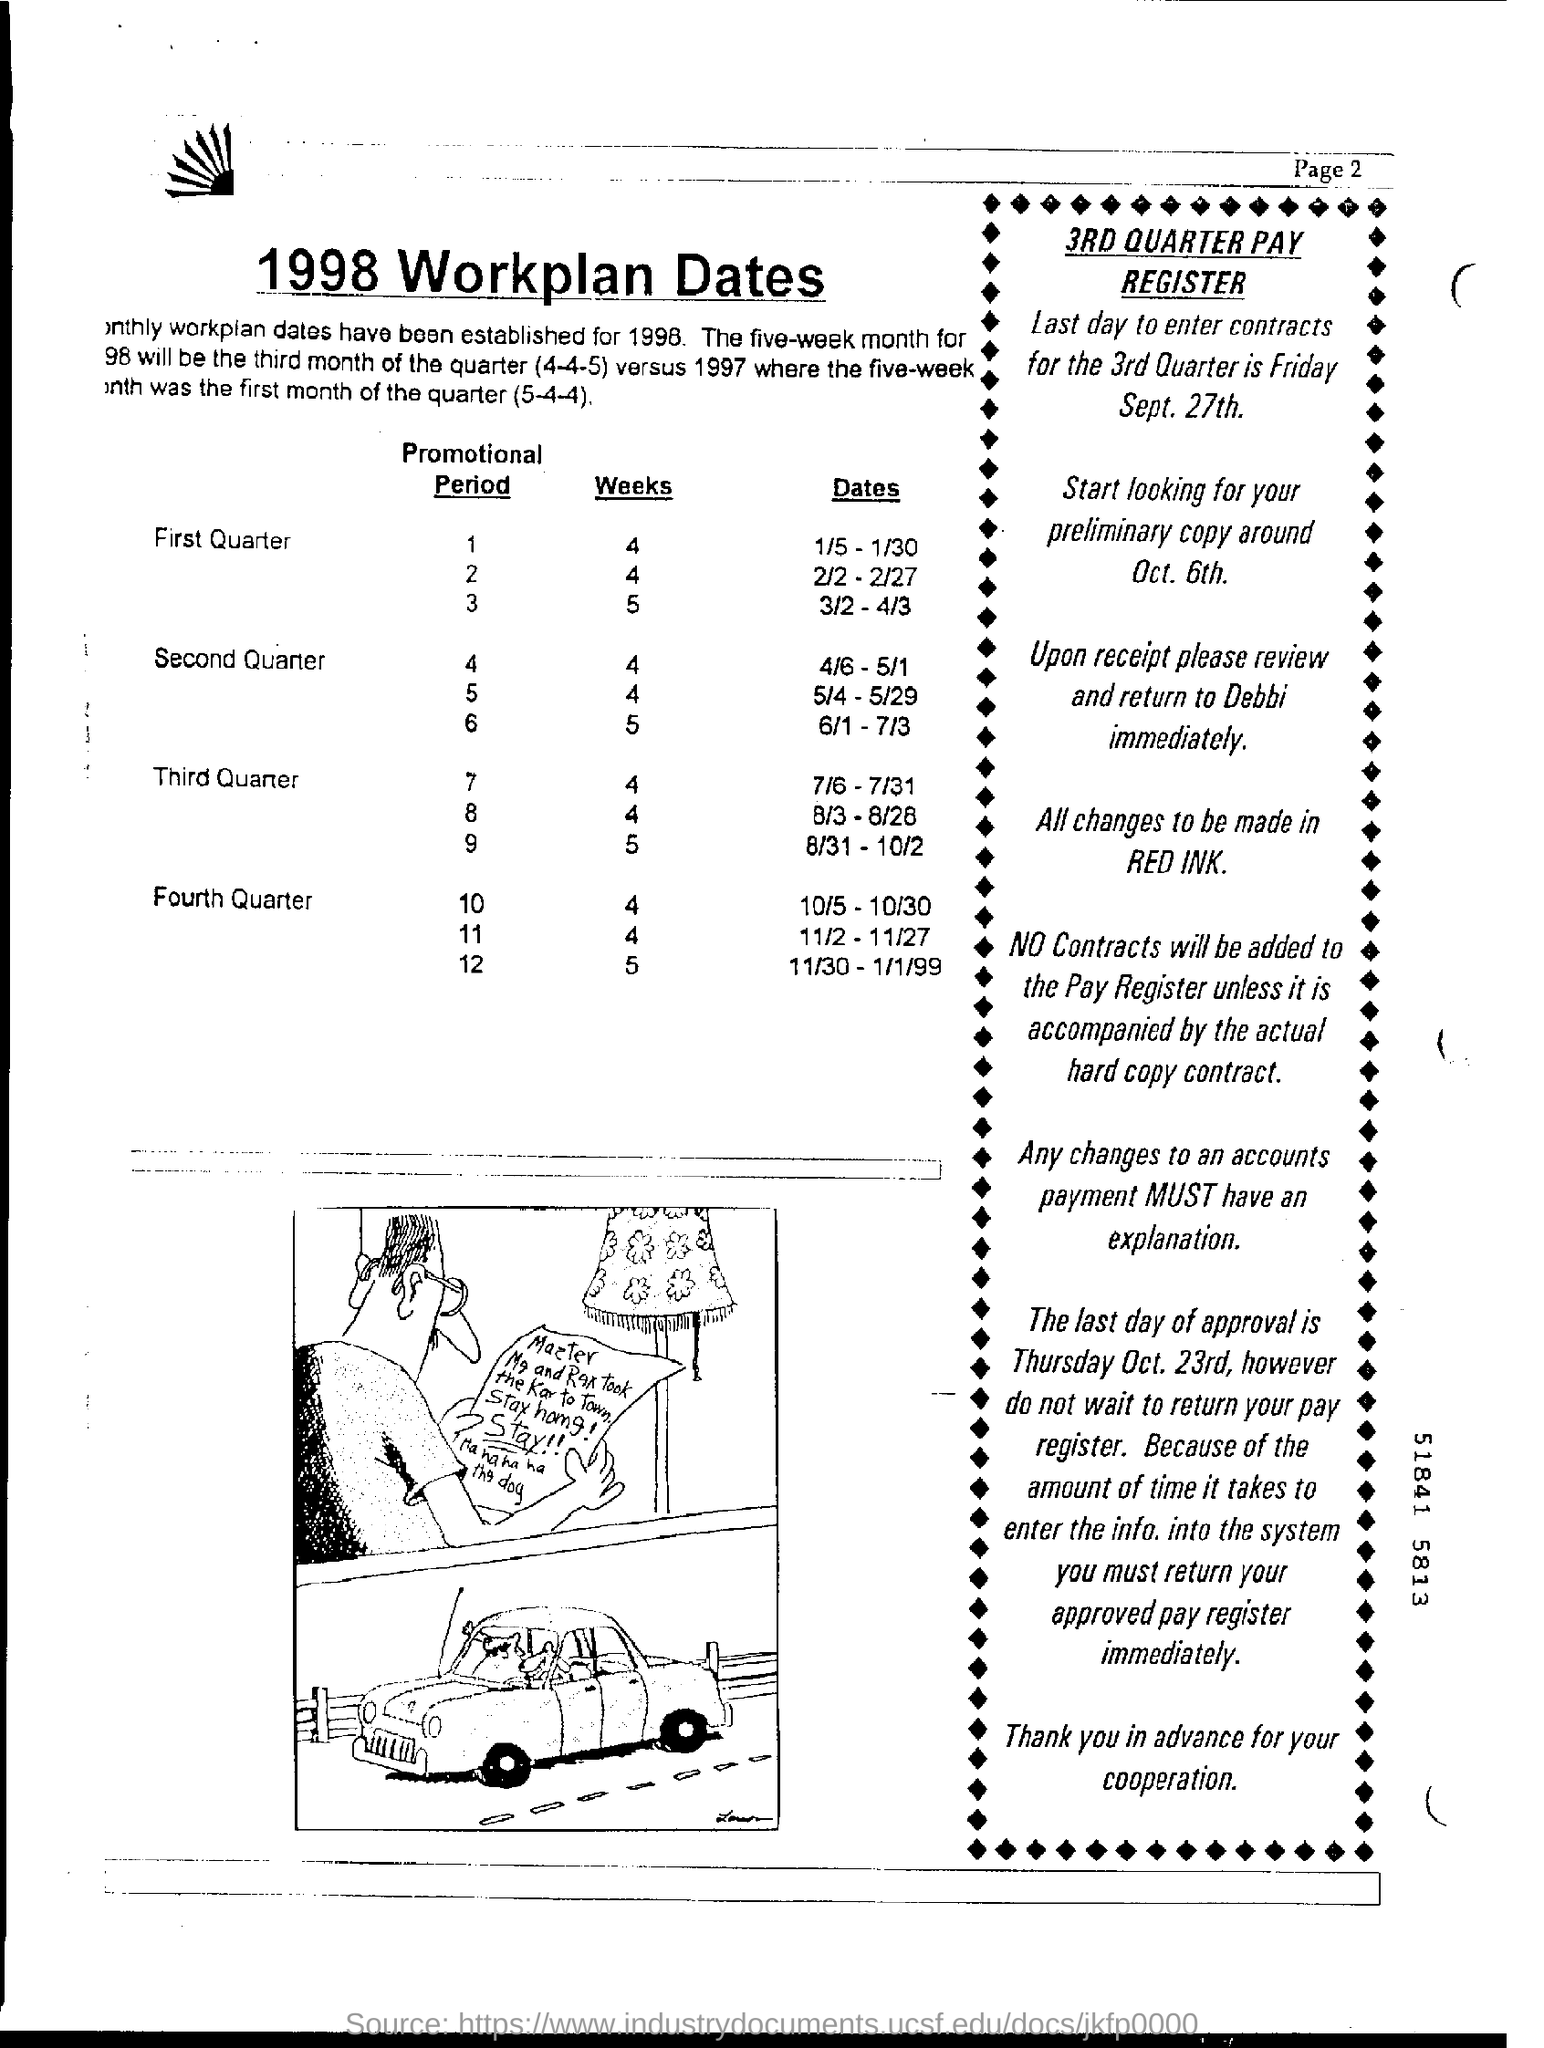What is the last day to enter contracts for the 3rd Quarter?
Offer a terse response. Friday Sept. 27th. When to look for preliminary copy?
Provide a succinct answer. Around oct. 6th. What is the last day of approval?
Your answer should be very brief. Thursday, Oct. 23rd. 